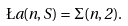Convert formula to latex. <formula><loc_0><loc_0><loc_500><loc_500>\L a ( n , S ) = \Sigma ( n , 2 ) .</formula> 